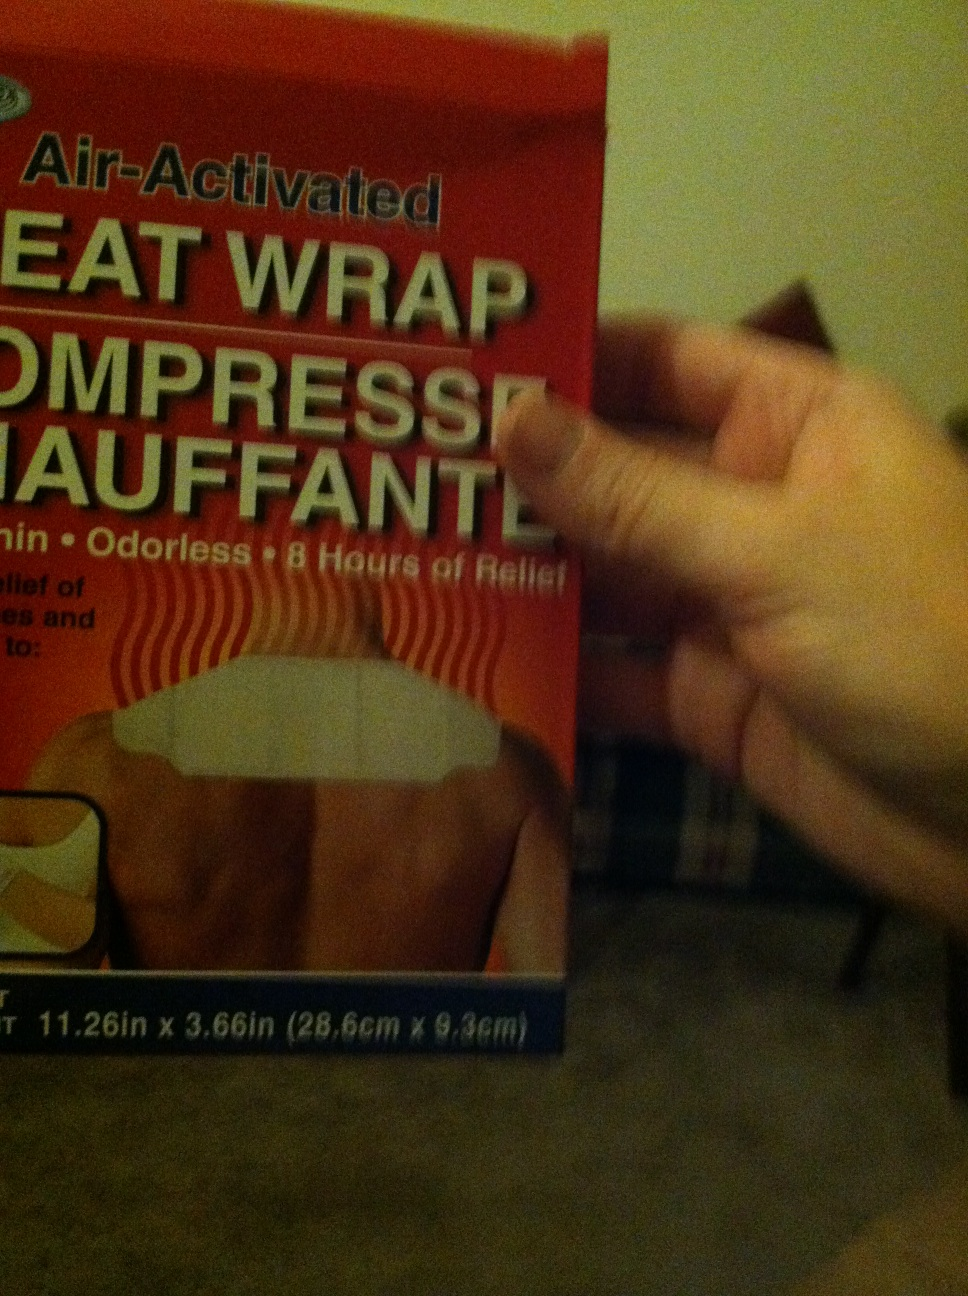How do you use this product correctly? To use the heat wrap, remove it from its packaging and shake it gently. The air-activation will begin the heating process. Place the wrap on the affected area over a layer of clothing to avoid direct skin contact. You can expect it to warm up within a few minutes and provide consistent heat for up to 8 hours. 